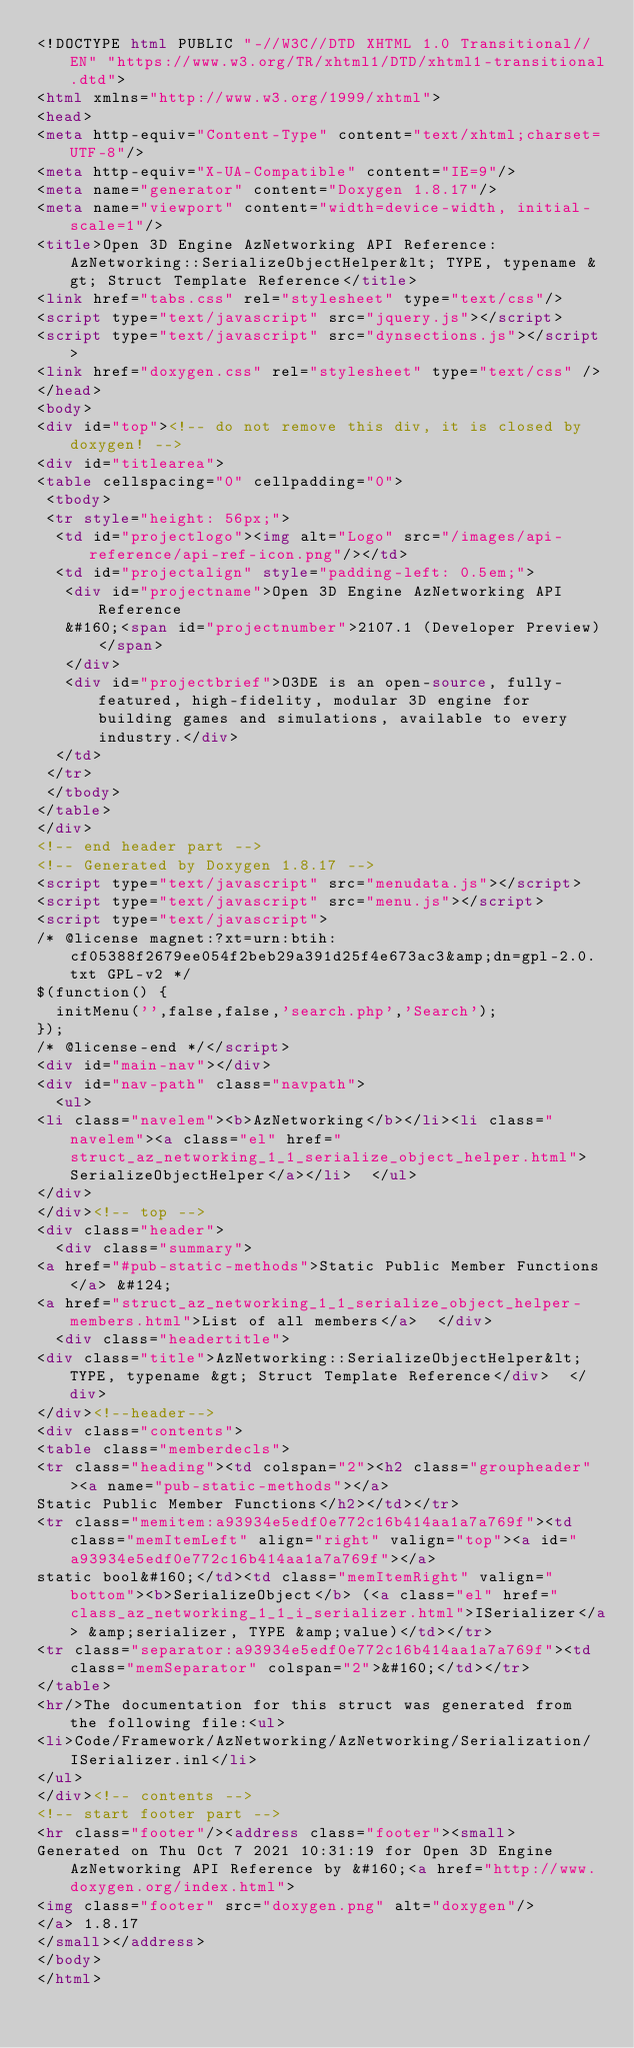Convert code to text. <code><loc_0><loc_0><loc_500><loc_500><_HTML_><!DOCTYPE html PUBLIC "-//W3C//DTD XHTML 1.0 Transitional//EN" "https://www.w3.org/TR/xhtml1/DTD/xhtml1-transitional.dtd">
<html xmlns="http://www.w3.org/1999/xhtml">
<head>
<meta http-equiv="Content-Type" content="text/xhtml;charset=UTF-8"/>
<meta http-equiv="X-UA-Compatible" content="IE=9"/>
<meta name="generator" content="Doxygen 1.8.17"/>
<meta name="viewport" content="width=device-width, initial-scale=1"/>
<title>Open 3D Engine AzNetworking API Reference: AzNetworking::SerializeObjectHelper&lt; TYPE, typename &gt; Struct Template Reference</title>
<link href="tabs.css" rel="stylesheet" type="text/css"/>
<script type="text/javascript" src="jquery.js"></script>
<script type="text/javascript" src="dynsections.js"></script>
<link href="doxygen.css" rel="stylesheet" type="text/css" />
</head>
<body>
<div id="top"><!-- do not remove this div, it is closed by doxygen! -->
<div id="titlearea">
<table cellspacing="0" cellpadding="0">
 <tbody>
 <tr style="height: 56px;">
  <td id="projectlogo"><img alt="Logo" src="/images/api-reference/api-ref-icon.png"/></td>
  <td id="projectalign" style="padding-left: 0.5em;">
   <div id="projectname">Open 3D Engine AzNetworking API Reference
   &#160;<span id="projectnumber">2107.1 (Developer Preview)</span>
   </div>
   <div id="projectbrief">O3DE is an open-source, fully-featured, high-fidelity, modular 3D engine for building games and simulations, available to every industry.</div>
  </td>
 </tr>
 </tbody>
</table>
</div>
<!-- end header part -->
<!-- Generated by Doxygen 1.8.17 -->
<script type="text/javascript" src="menudata.js"></script>
<script type="text/javascript" src="menu.js"></script>
<script type="text/javascript">
/* @license magnet:?xt=urn:btih:cf05388f2679ee054f2beb29a391d25f4e673ac3&amp;dn=gpl-2.0.txt GPL-v2 */
$(function() {
  initMenu('',false,false,'search.php','Search');
});
/* @license-end */</script>
<div id="main-nav"></div>
<div id="nav-path" class="navpath">
  <ul>
<li class="navelem"><b>AzNetworking</b></li><li class="navelem"><a class="el" href="struct_az_networking_1_1_serialize_object_helper.html">SerializeObjectHelper</a></li>  </ul>
</div>
</div><!-- top -->
<div class="header">
  <div class="summary">
<a href="#pub-static-methods">Static Public Member Functions</a> &#124;
<a href="struct_az_networking_1_1_serialize_object_helper-members.html">List of all members</a>  </div>
  <div class="headertitle">
<div class="title">AzNetworking::SerializeObjectHelper&lt; TYPE, typename &gt; Struct Template Reference</div>  </div>
</div><!--header-->
<div class="contents">
<table class="memberdecls">
<tr class="heading"><td colspan="2"><h2 class="groupheader"><a name="pub-static-methods"></a>
Static Public Member Functions</h2></td></tr>
<tr class="memitem:a93934e5edf0e772c16b414aa1a7a769f"><td class="memItemLeft" align="right" valign="top"><a id="a93934e5edf0e772c16b414aa1a7a769f"></a>
static bool&#160;</td><td class="memItemRight" valign="bottom"><b>SerializeObject</b> (<a class="el" href="class_az_networking_1_1_i_serializer.html">ISerializer</a> &amp;serializer, TYPE &amp;value)</td></tr>
<tr class="separator:a93934e5edf0e772c16b414aa1a7a769f"><td class="memSeparator" colspan="2">&#160;</td></tr>
</table>
<hr/>The documentation for this struct was generated from the following file:<ul>
<li>Code/Framework/AzNetworking/AzNetworking/Serialization/ISerializer.inl</li>
</ul>
</div><!-- contents -->
<!-- start footer part -->
<hr class="footer"/><address class="footer"><small>
Generated on Thu Oct 7 2021 10:31:19 for Open 3D Engine AzNetworking API Reference by &#160;<a href="http://www.doxygen.org/index.html">
<img class="footer" src="doxygen.png" alt="doxygen"/>
</a> 1.8.17
</small></address>
</body>
</html>
</code> 